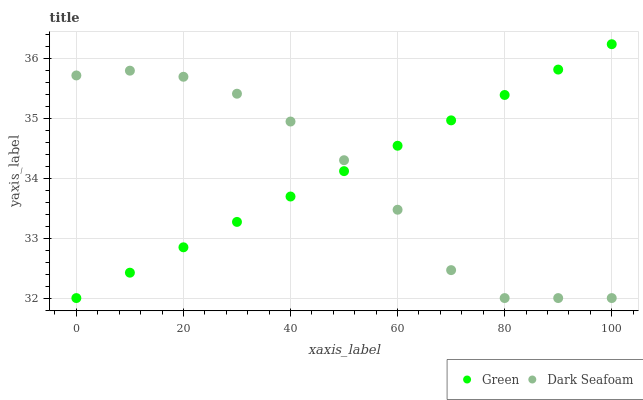Does Dark Seafoam have the minimum area under the curve?
Answer yes or no. Yes. Does Green have the maximum area under the curve?
Answer yes or no. Yes. Does Green have the minimum area under the curve?
Answer yes or no. No. Is Green the smoothest?
Answer yes or no. Yes. Is Dark Seafoam the roughest?
Answer yes or no. Yes. Is Green the roughest?
Answer yes or no. No. Does Dark Seafoam have the lowest value?
Answer yes or no. Yes. Does Green have the highest value?
Answer yes or no. Yes. Does Green intersect Dark Seafoam?
Answer yes or no. Yes. Is Green less than Dark Seafoam?
Answer yes or no. No. Is Green greater than Dark Seafoam?
Answer yes or no. No. 